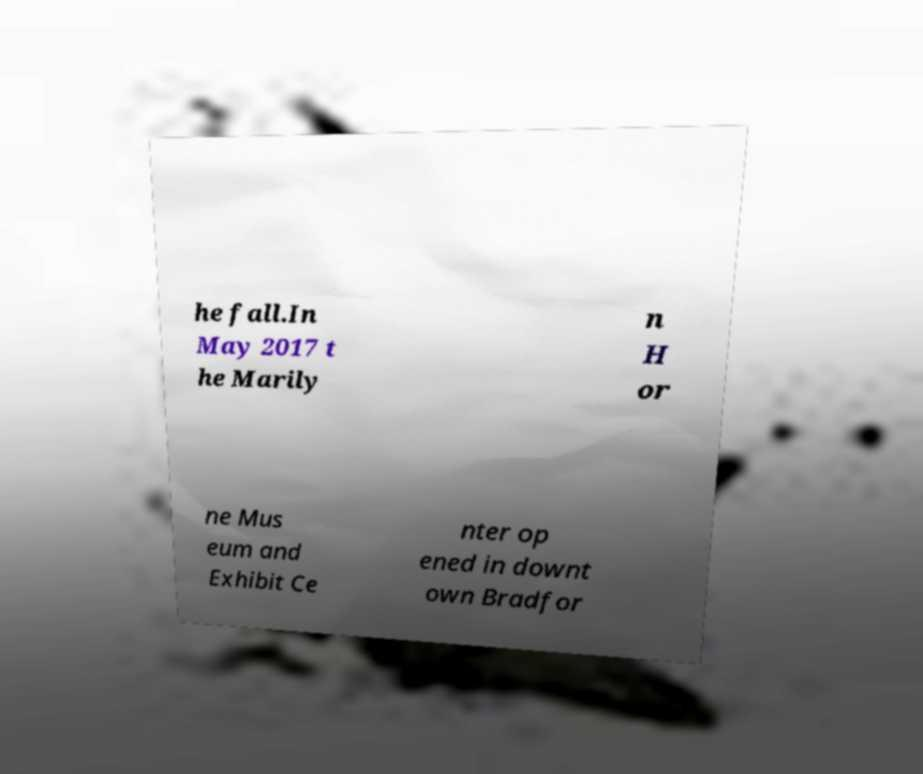Could you extract and type out the text from this image? he fall.In May 2017 t he Marily n H or ne Mus eum and Exhibit Ce nter op ened in downt own Bradfor 